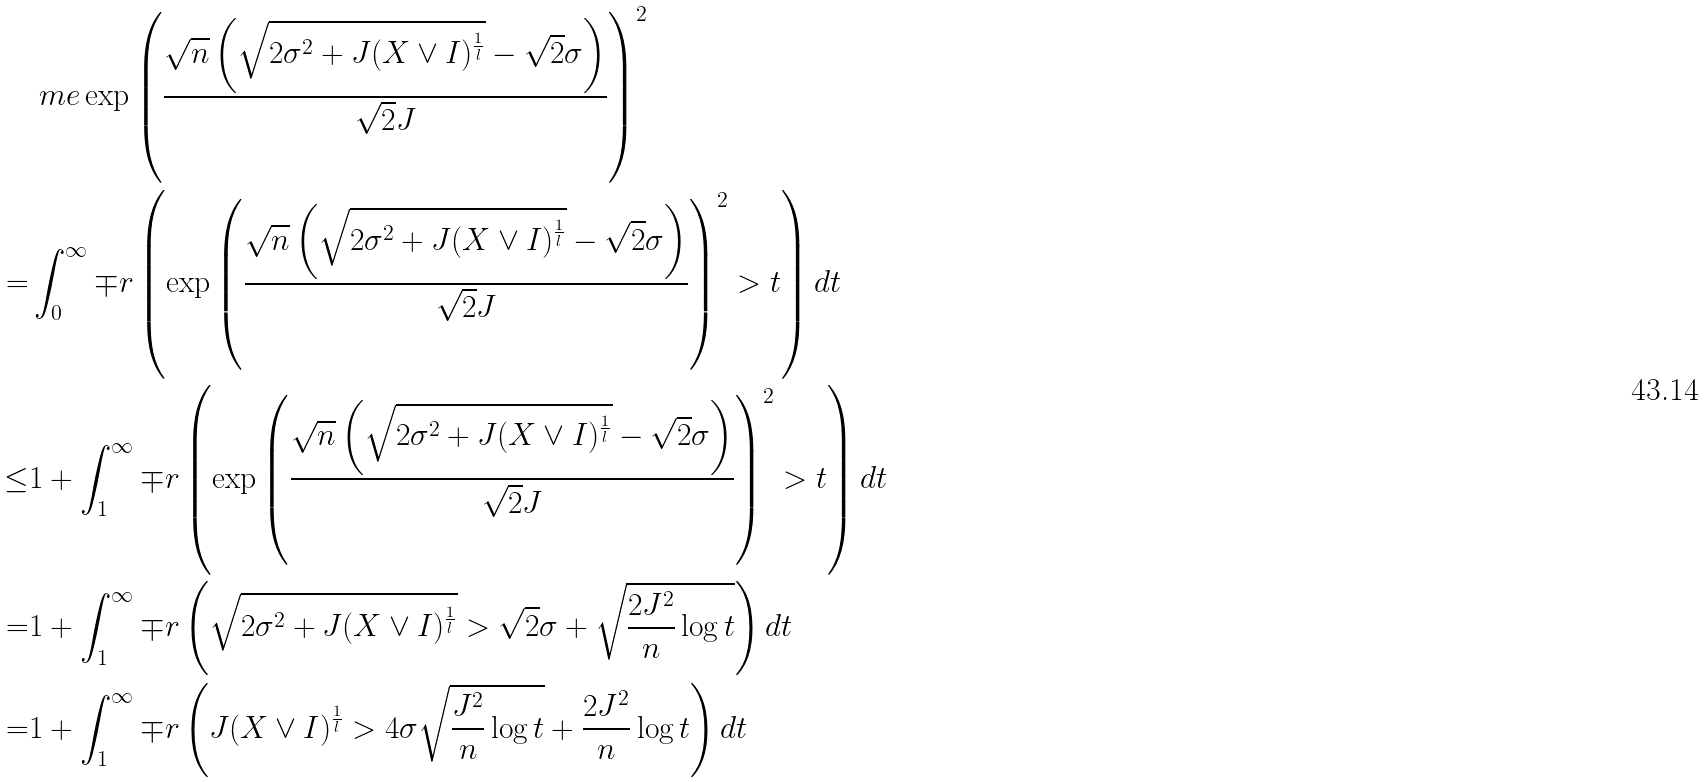<formula> <loc_0><loc_0><loc_500><loc_500>& \ m e \exp \left ( \frac { \sqrt { n } \left ( \sqrt { 2 \sigma ^ { 2 } + J ( X \vee I ) ^ { \frac { 1 } { l } } } - \sqrt { 2 } \sigma \right ) } { \sqrt { 2 } J } \right ) ^ { 2 } \\ = & \int _ { 0 } ^ { \infty } \mp r \left ( \exp \left ( \frac { \sqrt { n } \left ( \sqrt { 2 \sigma ^ { 2 } + J ( X \vee I ) ^ { \frac { 1 } { l } } } - \sqrt { 2 } \sigma \right ) } { \sqrt { 2 } J } \right ) ^ { 2 } > t \right ) d t \\ \leq & 1 + \int _ { 1 } ^ { \infty } \mp r \left ( \exp \left ( \frac { \sqrt { n } \left ( \sqrt { 2 \sigma ^ { 2 } + J ( X \vee I ) ^ { \frac { 1 } { l } } } - \sqrt { 2 } \sigma \right ) } { \sqrt { 2 } J } \right ) ^ { 2 } > t \right ) d t \\ = & 1 + \int _ { 1 } ^ { \infty } \mp r \left ( \sqrt { 2 \sigma ^ { 2 } + J ( X \vee I ) ^ { \frac { 1 } { l } } } > \sqrt { 2 } \sigma + \sqrt { \frac { 2 J ^ { 2 } } { n } \log t } \right ) d t \\ = & 1 + \int _ { 1 } ^ { \infty } \mp r \left ( J ( X \vee I ) ^ { \frac { 1 } { l } } > 4 \sigma \sqrt { \frac { J ^ { 2 } } { n } \log t } + \frac { 2 J ^ { 2 } } { n } \log t \right ) d t</formula> 